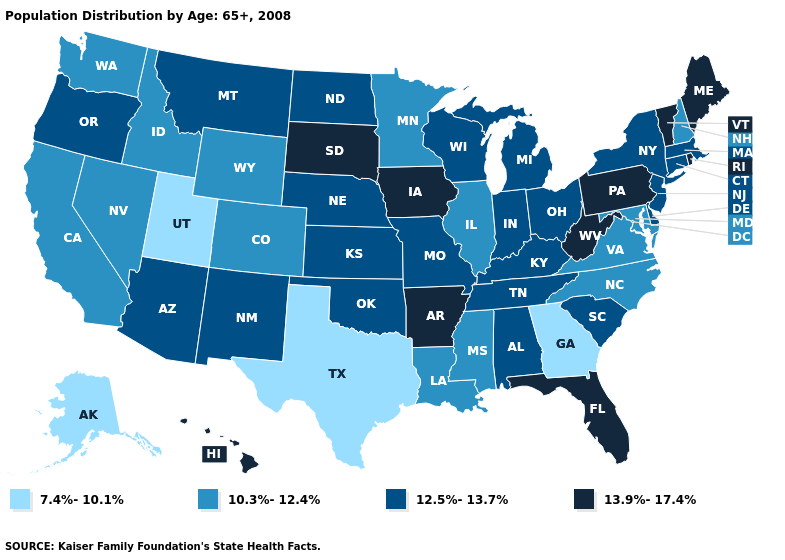What is the value of Alaska?
Write a very short answer. 7.4%-10.1%. Does New York have a higher value than Virginia?
Short answer required. Yes. Name the states that have a value in the range 10.3%-12.4%?
Be succinct. California, Colorado, Idaho, Illinois, Louisiana, Maryland, Minnesota, Mississippi, Nevada, New Hampshire, North Carolina, Virginia, Washington, Wyoming. Does Rhode Island have the same value as Arkansas?
Keep it brief. Yes. Name the states that have a value in the range 7.4%-10.1%?
Keep it brief. Alaska, Georgia, Texas, Utah. Which states have the lowest value in the USA?
Concise answer only. Alaska, Georgia, Texas, Utah. What is the highest value in states that border Maryland?
Write a very short answer. 13.9%-17.4%. What is the value of Michigan?
Keep it brief. 12.5%-13.7%. What is the highest value in states that border Massachusetts?
Keep it brief. 13.9%-17.4%. What is the value of Michigan?
Keep it brief. 12.5%-13.7%. Which states hav the highest value in the West?
Short answer required. Hawaii. Name the states that have a value in the range 13.9%-17.4%?
Write a very short answer. Arkansas, Florida, Hawaii, Iowa, Maine, Pennsylvania, Rhode Island, South Dakota, Vermont, West Virginia. Does Florida have the highest value in the South?
Short answer required. Yes. Name the states that have a value in the range 12.5%-13.7%?
Be succinct. Alabama, Arizona, Connecticut, Delaware, Indiana, Kansas, Kentucky, Massachusetts, Michigan, Missouri, Montana, Nebraska, New Jersey, New Mexico, New York, North Dakota, Ohio, Oklahoma, Oregon, South Carolina, Tennessee, Wisconsin. Does Indiana have a higher value than Idaho?
Give a very brief answer. Yes. 